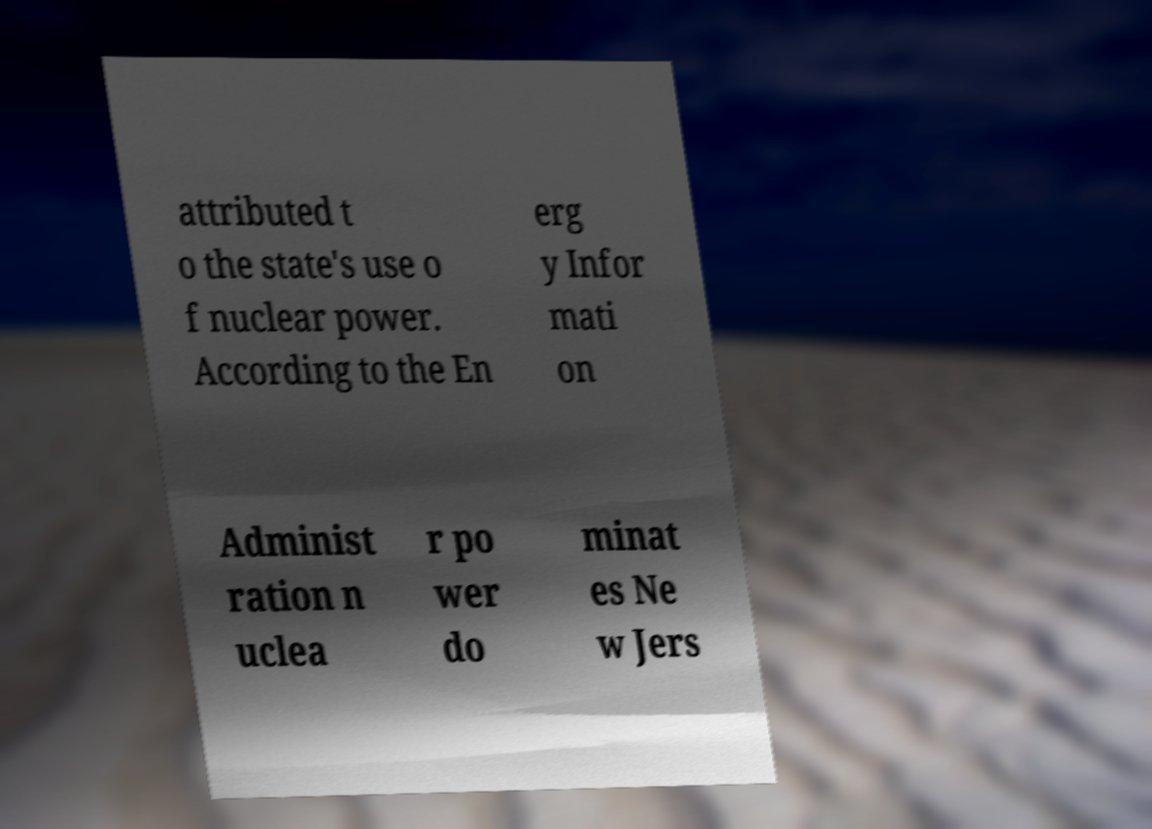I need the written content from this picture converted into text. Can you do that? attributed t o the state's use o f nuclear power. According to the En erg y Infor mati on Administ ration n uclea r po wer do minat es Ne w Jers 